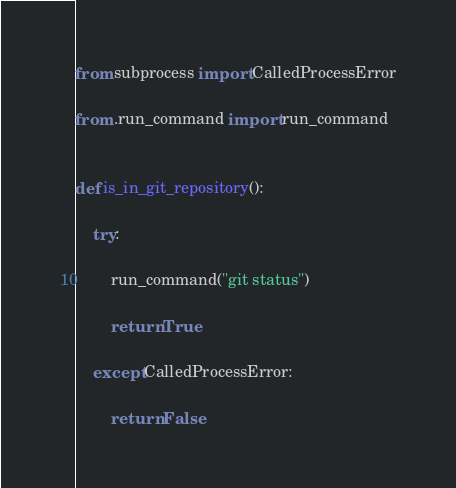Convert code to text. <code><loc_0><loc_0><loc_500><loc_500><_Python_>from subprocess import CalledProcessError

from .run_command import run_command


def is_in_git_repository():

    try:

        run_command("git status")

        return True

    except CalledProcessError:

        return False
</code> 